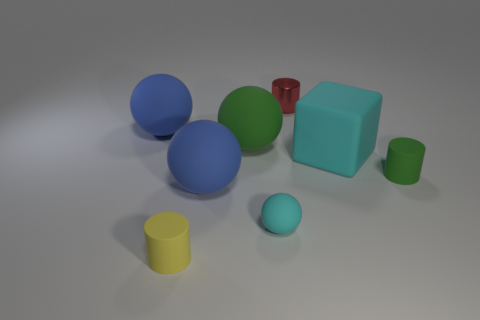What can you tell me about the texture of the objects? The objects exhibit different textures: the spheres and cylinders appear smooth and glossy, while the cubes have a matte finish, which diffuses the light and gives a softer look. 